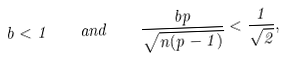<formula> <loc_0><loc_0><loc_500><loc_500>b < 1 \quad a n d \quad \frac { b p } { \sqrt { n ( p - 1 ) } } < \frac { 1 } { \sqrt { 2 } } ,</formula> 